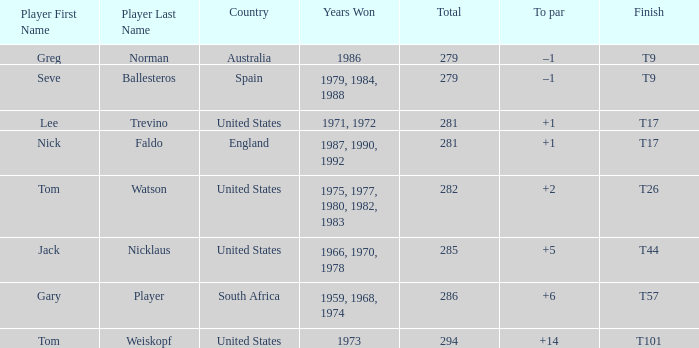What country is Greg Norman from? Australia. 